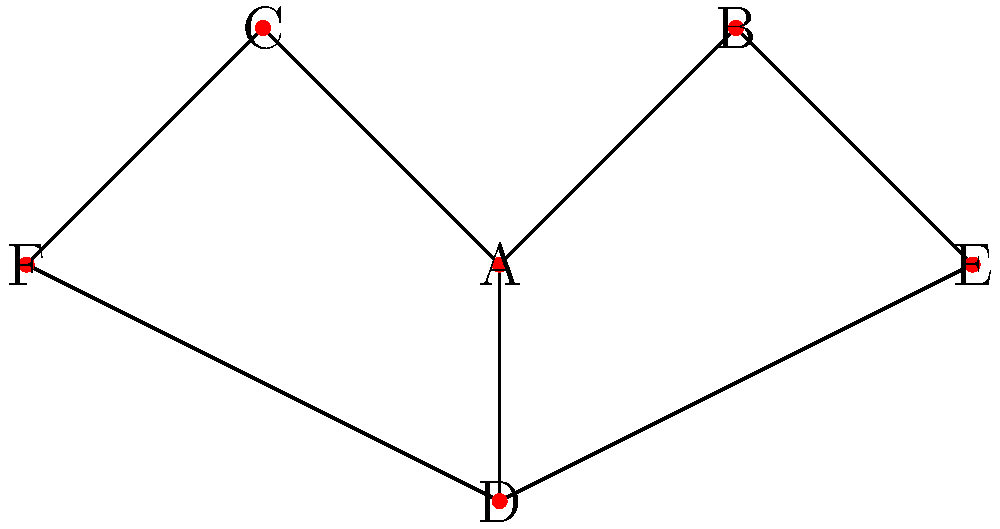In the network diagram representing character relationships in a screenplay, which character serves as the central node connecting all other characters, and how many direct connections does this character have? To answer this question, we need to analyze the network diagram:

1. Identify all characters (nodes) in the diagram:
   A, B, C, D, E, and F

2. Count the connections (edges) for each character:
   A: 3 connections (to B, C, and D)
   B: 2 connections (to A and E)
   C: 2 connections (to A and F)
   D: 3 connections (to A, E, and F)
   E: 2 connections (to B and D)
   F: 2 connections (to C and D)

3. Determine the central character:
   The central character is the one with the most connections and links to all other characters. In this case, it's character A.

4. Count the direct connections of the central character:
   Character A has 3 direct connections (to B, C, and D).

Therefore, the central node connecting all other characters is A, and it has 3 direct connections.
Answer: Character A, 3 connections 